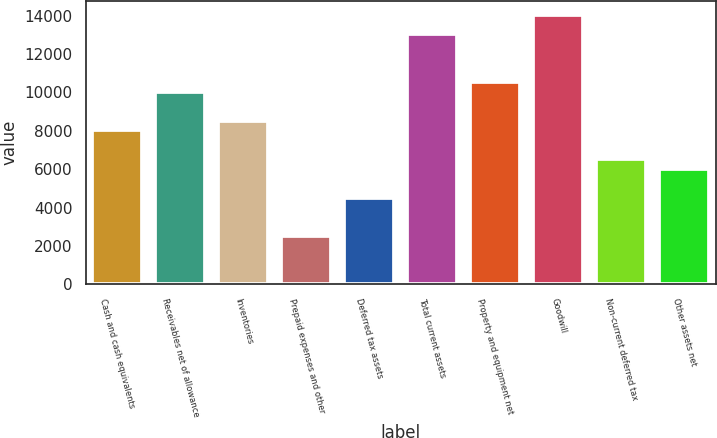Convert chart. <chart><loc_0><loc_0><loc_500><loc_500><bar_chart><fcel>Cash and cash equivalents<fcel>Receivables net of allowance<fcel>Inventories<fcel>Prepaid expenses and other<fcel>Deferred tax assets<fcel>Total current assets<fcel>Property and equipment net<fcel>Goodwill<fcel>Non-current deferred tax<fcel>Other assets net<nl><fcel>8032.9<fcel>10040.9<fcel>8534.9<fcel>2510.9<fcel>4518.9<fcel>13052.9<fcel>10542.9<fcel>14056.9<fcel>6526.9<fcel>6024.9<nl></chart> 